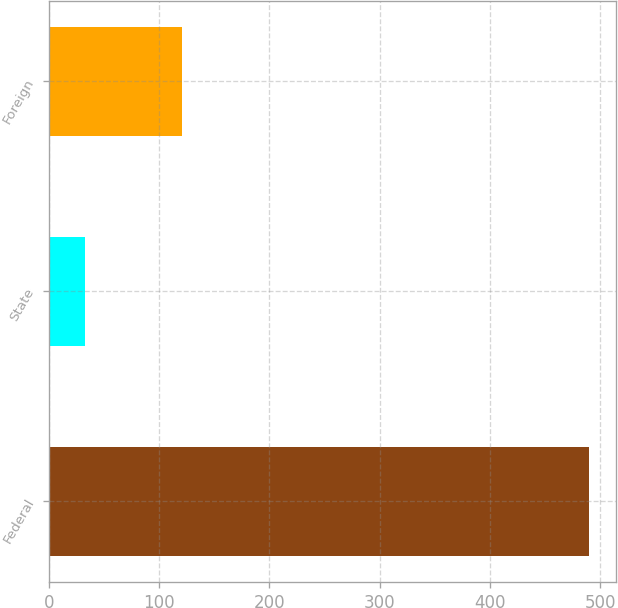<chart> <loc_0><loc_0><loc_500><loc_500><bar_chart><fcel>Federal<fcel>State<fcel>Foreign<nl><fcel>490<fcel>33<fcel>121<nl></chart> 